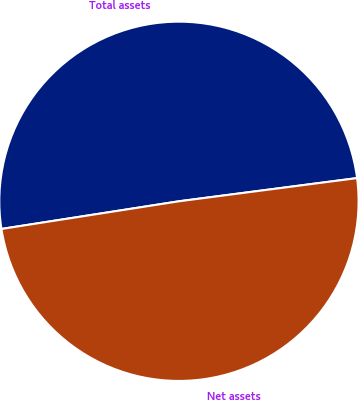Convert chart to OTSL. <chart><loc_0><loc_0><loc_500><loc_500><pie_chart><fcel>Total assets<fcel>Net assets<nl><fcel>50.4%<fcel>49.6%<nl></chart> 